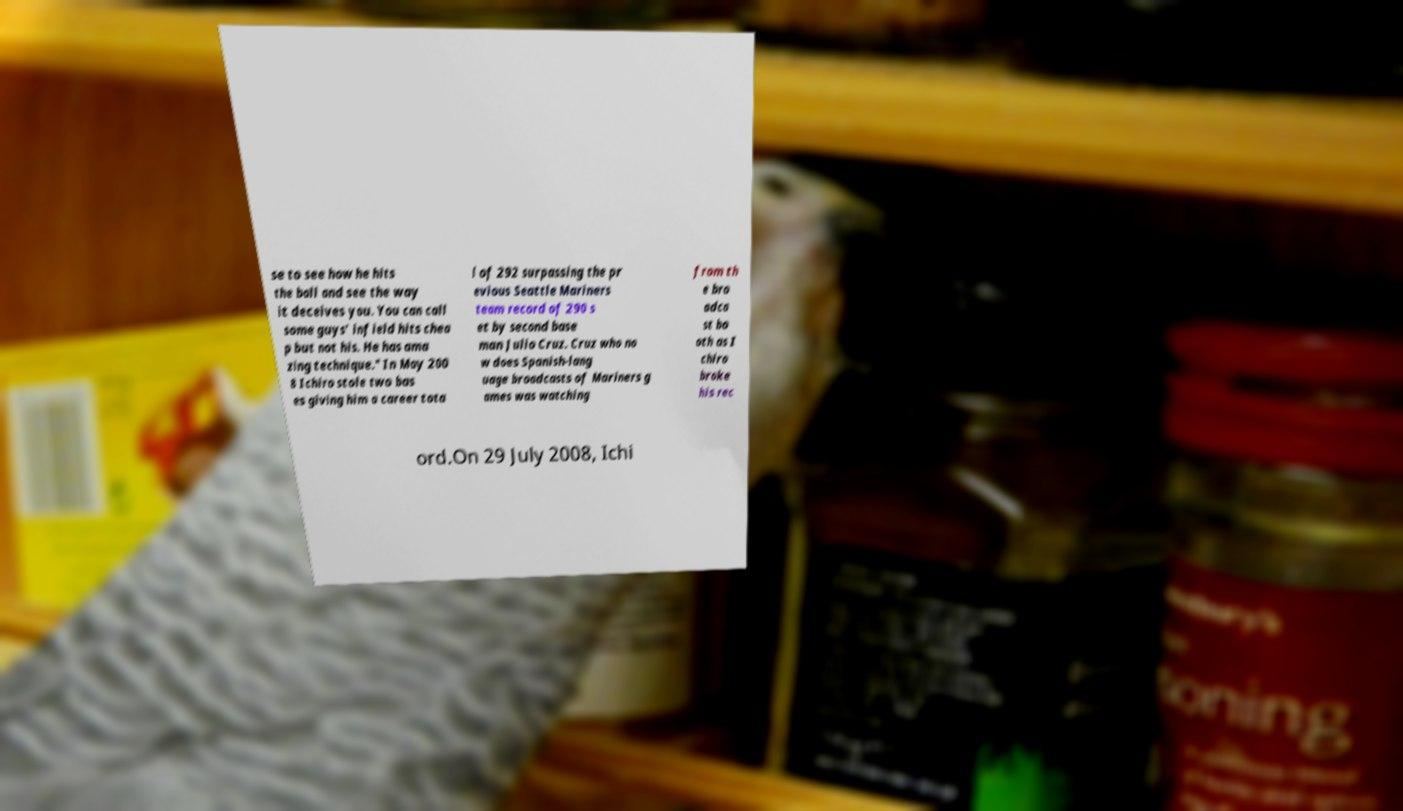Can you accurately transcribe the text from the provided image for me? se to see how he hits the ball and see the way it deceives you. You can call some guys' infield hits chea p but not his. He has ama zing technique." In May 200 8 Ichiro stole two bas es giving him a career tota l of 292 surpassing the pr evious Seattle Mariners team record of 290 s et by second base man Julio Cruz. Cruz who no w does Spanish-lang uage broadcasts of Mariners g ames was watching from th e bro adca st bo oth as I chiro broke his rec ord.On 29 July 2008, Ichi 